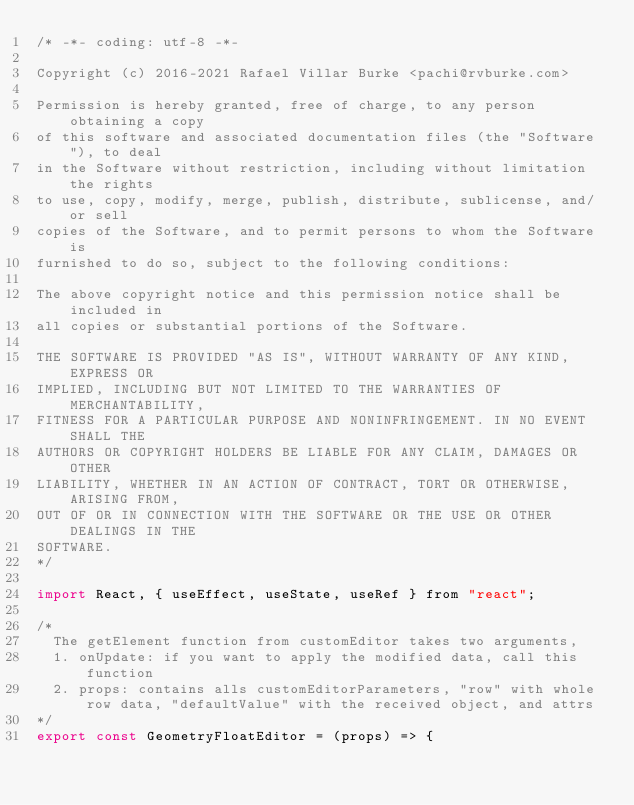<code> <loc_0><loc_0><loc_500><loc_500><_JavaScript_>/* -*- coding: utf-8 -*-

Copyright (c) 2016-2021 Rafael Villar Burke <pachi@rvburke.com>

Permission is hereby granted, free of charge, to any person obtaining a copy
of this software and associated documentation files (the "Software"), to deal
in the Software without restriction, including without limitation the rights
to use, copy, modify, merge, publish, distribute, sublicense, and/or sell
copies of the Software, and to permit persons to whom the Software is
furnished to do so, subject to the following conditions:

The above copyright notice and this permission notice shall be included in
all copies or substantial portions of the Software.

THE SOFTWARE IS PROVIDED "AS IS", WITHOUT WARRANTY OF ANY KIND, EXPRESS OR
IMPLIED, INCLUDING BUT NOT LIMITED TO THE WARRANTIES OF MERCHANTABILITY,
FITNESS FOR A PARTICULAR PURPOSE AND NONINFRINGEMENT. IN NO EVENT SHALL THE
AUTHORS OR COPYRIGHT HOLDERS BE LIABLE FOR ANY CLAIM, DAMAGES OR OTHER
LIABILITY, WHETHER IN AN ACTION OF CONTRACT, TORT OR OTHERWISE, ARISING FROM,
OUT OF OR IN CONNECTION WITH THE SOFTWARE OR THE USE OR OTHER DEALINGS IN THE
SOFTWARE.
*/

import React, { useEffect, useState, useRef } from "react";

/*
  The getElement function from customEditor takes two arguments,
  1. onUpdate: if you want to apply the modified data, call this function
  2. props: contains alls customEditorParameters, "row" with whole row data, "defaultValue" with the received object, and attrs
*/
export const GeometryFloatEditor = (props) => {</code> 